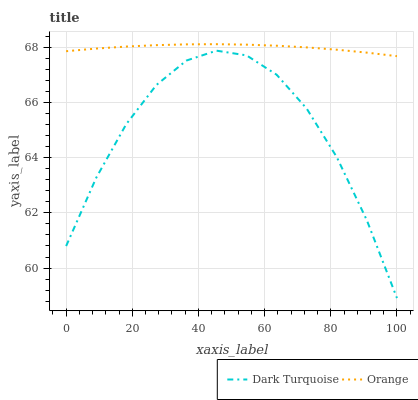Does Dark Turquoise have the minimum area under the curve?
Answer yes or no. Yes. Does Orange have the maximum area under the curve?
Answer yes or no. Yes. Does Dark Turquoise have the maximum area under the curve?
Answer yes or no. No. Is Orange the smoothest?
Answer yes or no. Yes. Is Dark Turquoise the roughest?
Answer yes or no. Yes. Is Dark Turquoise the smoothest?
Answer yes or no. No. Does Dark Turquoise have the lowest value?
Answer yes or no. Yes. Does Orange have the highest value?
Answer yes or no. Yes. Does Dark Turquoise have the highest value?
Answer yes or no. No. Is Dark Turquoise less than Orange?
Answer yes or no. Yes. Is Orange greater than Dark Turquoise?
Answer yes or no. Yes. Does Dark Turquoise intersect Orange?
Answer yes or no. No. 